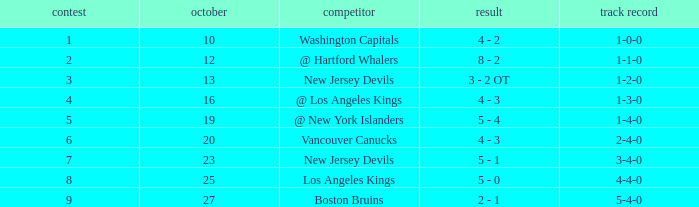What was the average game with a record of 4-4-0? 8.0. 